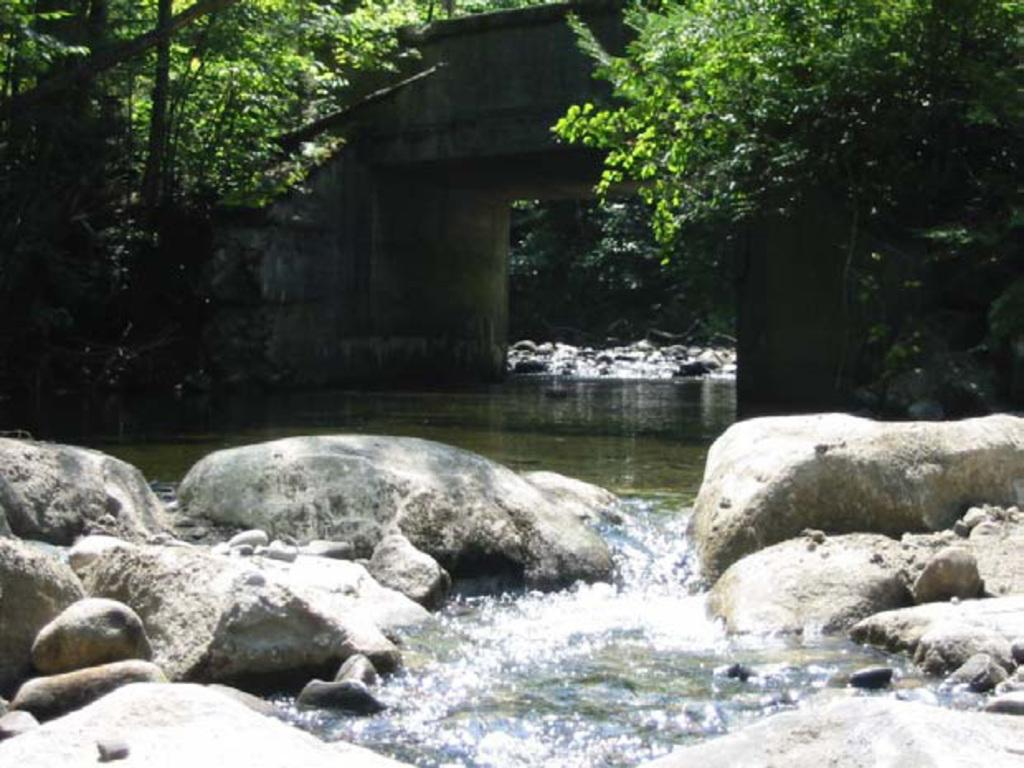What type of natural elements can be seen in the image? There are rocks and water visible in the image. What can be seen in the background of the image? There are trees and a bridge in the background of the image. What type of jelly can be seen on the rocks in the image? There is no jelly present on the rocks in the image. What type of fork is used to eat the water in the image? There is no fork present in the image, and water is not something that is typically eaten with a fork. 